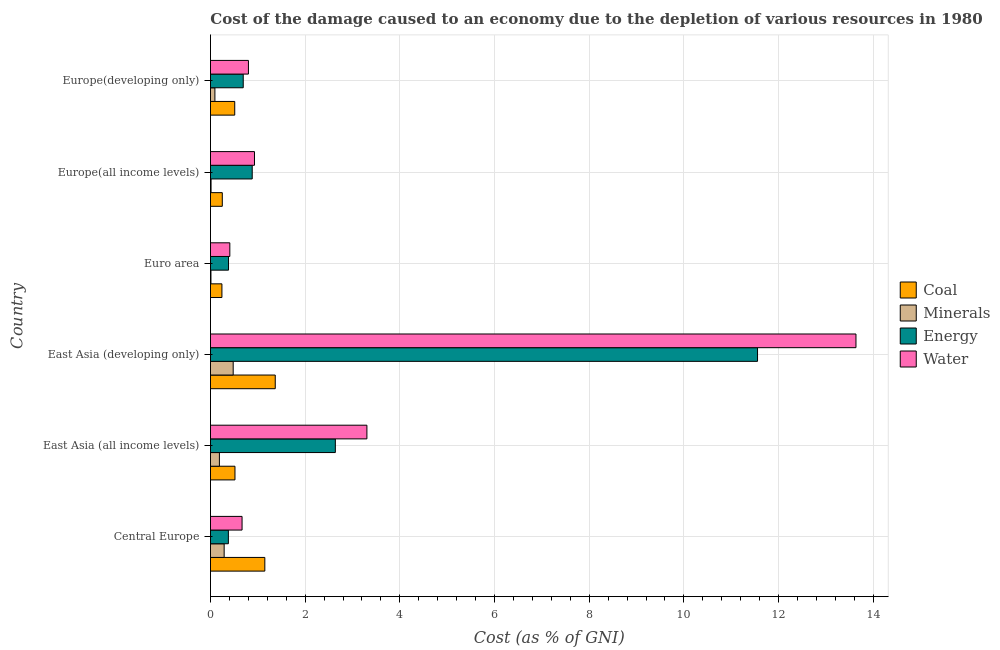How many groups of bars are there?
Make the answer very short. 6. Are the number of bars per tick equal to the number of legend labels?
Your answer should be very brief. Yes. What is the label of the 2nd group of bars from the top?
Give a very brief answer. Europe(all income levels). What is the cost of damage due to depletion of minerals in Euro area?
Keep it short and to the point. 0.01. Across all countries, what is the maximum cost of damage due to depletion of energy?
Offer a terse response. 11.55. Across all countries, what is the minimum cost of damage due to depletion of coal?
Your response must be concise. 0.24. In which country was the cost of damage due to depletion of minerals maximum?
Keep it short and to the point. East Asia (developing only). What is the total cost of damage due to depletion of coal in the graph?
Ensure brevity in your answer.  4.04. What is the difference between the cost of damage due to depletion of coal in Central Europe and the cost of damage due to depletion of water in East Asia (all income levels)?
Offer a terse response. -2.16. What is the average cost of damage due to depletion of water per country?
Keep it short and to the point. 3.29. What is the difference between the cost of damage due to depletion of energy and cost of damage due to depletion of minerals in East Asia (all income levels)?
Provide a short and direct response. 2.45. In how many countries, is the cost of damage due to depletion of water greater than 1.6 %?
Make the answer very short. 2. What is the ratio of the cost of damage due to depletion of energy in East Asia (all income levels) to that in Europe(developing only)?
Give a very brief answer. 3.81. Is the difference between the cost of damage due to depletion of water in Central Europe and East Asia (developing only) greater than the difference between the cost of damage due to depletion of energy in Central Europe and East Asia (developing only)?
Offer a very short reply. No. What is the difference between the highest and the second highest cost of damage due to depletion of coal?
Ensure brevity in your answer.  0.22. What is the difference between the highest and the lowest cost of damage due to depletion of coal?
Your answer should be very brief. 1.13. In how many countries, is the cost of damage due to depletion of energy greater than the average cost of damage due to depletion of energy taken over all countries?
Provide a succinct answer. 1. Is the sum of the cost of damage due to depletion of coal in Central Europe and Europe(all income levels) greater than the maximum cost of damage due to depletion of energy across all countries?
Your response must be concise. No. What does the 3rd bar from the top in East Asia (all income levels) represents?
Ensure brevity in your answer.  Minerals. What does the 3rd bar from the bottom in Europe(developing only) represents?
Your response must be concise. Energy. Are all the bars in the graph horizontal?
Your answer should be compact. Yes. Are the values on the major ticks of X-axis written in scientific E-notation?
Make the answer very short. No. How many legend labels are there?
Make the answer very short. 4. What is the title of the graph?
Offer a very short reply. Cost of the damage caused to an economy due to the depletion of various resources in 1980 . Does "Agriculture" appear as one of the legend labels in the graph?
Keep it short and to the point. No. What is the label or title of the X-axis?
Offer a terse response. Cost (as % of GNI). What is the Cost (as % of GNI) in Coal in Central Europe?
Keep it short and to the point. 1.15. What is the Cost (as % of GNI) of Minerals in Central Europe?
Provide a succinct answer. 0.29. What is the Cost (as % of GNI) in Energy in Central Europe?
Ensure brevity in your answer.  0.38. What is the Cost (as % of GNI) of Water in Central Europe?
Ensure brevity in your answer.  0.67. What is the Cost (as % of GNI) of Coal in East Asia (all income levels)?
Give a very brief answer. 0.52. What is the Cost (as % of GNI) in Minerals in East Asia (all income levels)?
Offer a very short reply. 0.19. What is the Cost (as % of GNI) of Energy in East Asia (all income levels)?
Provide a short and direct response. 2.64. What is the Cost (as % of GNI) of Water in East Asia (all income levels)?
Keep it short and to the point. 3.3. What is the Cost (as % of GNI) of Coal in East Asia (developing only)?
Make the answer very short. 1.37. What is the Cost (as % of GNI) in Minerals in East Asia (developing only)?
Your response must be concise. 0.48. What is the Cost (as % of GNI) of Energy in East Asia (developing only)?
Your answer should be compact. 11.55. What is the Cost (as % of GNI) in Water in East Asia (developing only)?
Your response must be concise. 13.63. What is the Cost (as % of GNI) in Coal in Euro area?
Your response must be concise. 0.24. What is the Cost (as % of GNI) in Minerals in Euro area?
Provide a short and direct response. 0.01. What is the Cost (as % of GNI) of Energy in Euro area?
Provide a short and direct response. 0.38. What is the Cost (as % of GNI) in Water in Euro area?
Your response must be concise. 0.41. What is the Cost (as % of GNI) of Coal in Europe(all income levels)?
Keep it short and to the point. 0.25. What is the Cost (as % of GNI) of Minerals in Europe(all income levels)?
Offer a very short reply. 0.01. What is the Cost (as % of GNI) of Energy in Europe(all income levels)?
Provide a succinct answer. 0.88. What is the Cost (as % of GNI) of Water in Europe(all income levels)?
Keep it short and to the point. 0.93. What is the Cost (as % of GNI) in Coal in Europe(developing only)?
Offer a very short reply. 0.51. What is the Cost (as % of GNI) in Minerals in Europe(developing only)?
Ensure brevity in your answer.  0.09. What is the Cost (as % of GNI) of Energy in Europe(developing only)?
Provide a short and direct response. 0.69. What is the Cost (as % of GNI) of Water in Europe(developing only)?
Your response must be concise. 0.8. Across all countries, what is the maximum Cost (as % of GNI) in Coal?
Make the answer very short. 1.37. Across all countries, what is the maximum Cost (as % of GNI) of Minerals?
Keep it short and to the point. 0.48. Across all countries, what is the maximum Cost (as % of GNI) of Energy?
Provide a succinct answer. 11.55. Across all countries, what is the maximum Cost (as % of GNI) in Water?
Ensure brevity in your answer.  13.63. Across all countries, what is the minimum Cost (as % of GNI) in Coal?
Keep it short and to the point. 0.24. Across all countries, what is the minimum Cost (as % of GNI) in Minerals?
Your answer should be very brief. 0.01. Across all countries, what is the minimum Cost (as % of GNI) in Energy?
Your answer should be very brief. 0.38. Across all countries, what is the minimum Cost (as % of GNI) of Water?
Your answer should be compact. 0.41. What is the total Cost (as % of GNI) of Coal in the graph?
Keep it short and to the point. 4.04. What is the total Cost (as % of GNI) of Minerals in the graph?
Your answer should be compact. 1.07. What is the total Cost (as % of GNI) of Energy in the graph?
Your answer should be compact. 16.53. What is the total Cost (as % of GNI) in Water in the graph?
Make the answer very short. 19.75. What is the difference between the Cost (as % of GNI) of Coal in Central Europe and that in East Asia (all income levels)?
Offer a terse response. 0.63. What is the difference between the Cost (as % of GNI) of Minerals in Central Europe and that in East Asia (all income levels)?
Ensure brevity in your answer.  0.1. What is the difference between the Cost (as % of GNI) in Energy in Central Europe and that in East Asia (all income levels)?
Offer a terse response. -2.26. What is the difference between the Cost (as % of GNI) in Water in Central Europe and that in East Asia (all income levels)?
Ensure brevity in your answer.  -2.64. What is the difference between the Cost (as % of GNI) in Coal in Central Europe and that in East Asia (developing only)?
Make the answer very short. -0.22. What is the difference between the Cost (as % of GNI) of Minerals in Central Europe and that in East Asia (developing only)?
Provide a succinct answer. -0.19. What is the difference between the Cost (as % of GNI) in Energy in Central Europe and that in East Asia (developing only)?
Your response must be concise. -11.18. What is the difference between the Cost (as % of GNI) of Water in Central Europe and that in East Asia (developing only)?
Offer a terse response. -12.97. What is the difference between the Cost (as % of GNI) in Coal in Central Europe and that in Euro area?
Offer a terse response. 0.91. What is the difference between the Cost (as % of GNI) of Minerals in Central Europe and that in Euro area?
Make the answer very short. 0.28. What is the difference between the Cost (as % of GNI) of Energy in Central Europe and that in Euro area?
Your response must be concise. -0. What is the difference between the Cost (as % of GNI) of Water in Central Europe and that in Euro area?
Give a very brief answer. 0.26. What is the difference between the Cost (as % of GNI) of Coal in Central Europe and that in Europe(all income levels)?
Offer a very short reply. 0.9. What is the difference between the Cost (as % of GNI) in Minerals in Central Europe and that in Europe(all income levels)?
Your answer should be compact. 0.28. What is the difference between the Cost (as % of GNI) in Energy in Central Europe and that in Europe(all income levels)?
Provide a succinct answer. -0.5. What is the difference between the Cost (as % of GNI) of Water in Central Europe and that in Europe(all income levels)?
Your response must be concise. -0.26. What is the difference between the Cost (as % of GNI) of Coal in Central Europe and that in Europe(developing only)?
Offer a terse response. 0.64. What is the difference between the Cost (as % of GNI) of Minerals in Central Europe and that in Europe(developing only)?
Offer a terse response. 0.2. What is the difference between the Cost (as % of GNI) in Energy in Central Europe and that in Europe(developing only)?
Offer a terse response. -0.31. What is the difference between the Cost (as % of GNI) in Water in Central Europe and that in Europe(developing only)?
Ensure brevity in your answer.  -0.13. What is the difference between the Cost (as % of GNI) of Coal in East Asia (all income levels) and that in East Asia (developing only)?
Make the answer very short. -0.85. What is the difference between the Cost (as % of GNI) of Minerals in East Asia (all income levels) and that in East Asia (developing only)?
Give a very brief answer. -0.29. What is the difference between the Cost (as % of GNI) of Energy in East Asia (all income levels) and that in East Asia (developing only)?
Offer a terse response. -8.92. What is the difference between the Cost (as % of GNI) of Water in East Asia (all income levels) and that in East Asia (developing only)?
Provide a succinct answer. -10.33. What is the difference between the Cost (as % of GNI) in Coal in East Asia (all income levels) and that in Euro area?
Your answer should be compact. 0.28. What is the difference between the Cost (as % of GNI) of Minerals in East Asia (all income levels) and that in Euro area?
Provide a succinct answer. 0.18. What is the difference between the Cost (as % of GNI) in Energy in East Asia (all income levels) and that in Euro area?
Make the answer very short. 2.26. What is the difference between the Cost (as % of GNI) in Water in East Asia (all income levels) and that in Euro area?
Make the answer very short. 2.9. What is the difference between the Cost (as % of GNI) of Coal in East Asia (all income levels) and that in Europe(all income levels)?
Make the answer very short. 0.27. What is the difference between the Cost (as % of GNI) in Minerals in East Asia (all income levels) and that in Europe(all income levels)?
Make the answer very short. 0.18. What is the difference between the Cost (as % of GNI) in Energy in East Asia (all income levels) and that in Europe(all income levels)?
Ensure brevity in your answer.  1.76. What is the difference between the Cost (as % of GNI) in Water in East Asia (all income levels) and that in Europe(all income levels)?
Your response must be concise. 2.37. What is the difference between the Cost (as % of GNI) in Coal in East Asia (all income levels) and that in Europe(developing only)?
Keep it short and to the point. 0. What is the difference between the Cost (as % of GNI) of Minerals in East Asia (all income levels) and that in Europe(developing only)?
Your answer should be very brief. 0.1. What is the difference between the Cost (as % of GNI) of Energy in East Asia (all income levels) and that in Europe(developing only)?
Give a very brief answer. 1.95. What is the difference between the Cost (as % of GNI) in Water in East Asia (all income levels) and that in Europe(developing only)?
Offer a very short reply. 2.5. What is the difference between the Cost (as % of GNI) in Coal in East Asia (developing only) and that in Euro area?
Keep it short and to the point. 1.13. What is the difference between the Cost (as % of GNI) of Minerals in East Asia (developing only) and that in Euro area?
Ensure brevity in your answer.  0.47. What is the difference between the Cost (as % of GNI) in Energy in East Asia (developing only) and that in Euro area?
Offer a very short reply. 11.17. What is the difference between the Cost (as % of GNI) of Water in East Asia (developing only) and that in Euro area?
Provide a short and direct response. 13.22. What is the difference between the Cost (as % of GNI) of Coal in East Asia (developing only) and that in Europe(all income levels)?
Provide a short and direct response. 1.12. What is the difference between the Cost (as % of GNI) in Minerals in East Asia (developing only) and that in Europe(all income levels)?
Your answer should be very brief. 0.47. What is the difference between the Cost (as % of GNI) in Energy in East Asia (developing only) and that in Europe(all income levels)?
Offer a terse response. 10.67. What is the difference between the Cost (as % of GNI) of Water in East Asia (developing only) and that in Europe(all income levels)?
Your response must be concise. 12.7. What is the difference between the Cost (as % of GNI) in Coal in East Asia (developing only) and that in Europe(developing only)?
Ensure brevity in your answer.  0.86. What is the difference between the Cost (as % of GNI) of Minerals in East Asia (developing only) and that in Europe(developing only)?
Keep it short and to the point. 0.39. What is the difference between the Cost (as % of GNI) in Energy in East Asia (developing only) and that in Europe(developing only)?
Ensure brevity in your answer.  10.86. What is the difference between the Cost (as % of GNI) of Water in East Asia (developing only) and that in Europe(developing only)?
Keep it short and to the point. 12.83. What is the difference between the Cost (as % of GNI) in Coal in Euro area and that in Europe(all income levels)?
Keep it short and to the point. -0.01. What is the difference between the Cost (as % of GNI) in Minerals in Euro area and that in Europe(all income levels)?
Offer a terse response. -0. What is the difference between the Cost (as % of GNI) of Energy in Euro area and that in Europe(all income levels)?
Provide a short and direct response. -0.5. What is the difference between the Cost (as % of GNI) in Water in Euro area and that in Europe(all income levels)?
Give a very brief answer. -0.52. What is the difference between the Cost (as % of GNI) of Coal in Euro area and that in Europe(developing only)?
Make the answer very short. -0.27. What is the difference between the Cost (as % of GNI) of Minerals in Euro area and that in Europe(developing only)?
Offer a very short reply. -0.08. What is the difference between the Cost (as % of GNI) in Energy in Euro area and that in Europe(developing only)?
Make the answer very short. -0.31. What is the difference between the Cost (as % of GNI) in Water in Euro area and that in Europe(developing only)?
Provide a succinct answer. -0.39. What is the difference between the Cost (as % of GNI) in Coal in Europe(all income levels) and that in Europe(developing only)?
Keep it short and to the point. -0.26. What is the difference between the Cost (as % of GNI) of Minerals in Europe(all income levels) and that in Europe(developing only)?
Your answer should be compact. -0.08. What is the difference between the Cost (as % of GNI) in Energy in Europe(all income levels) and that in Europe(developing only)?
Your response must be concise. 0.19. What is the difference between the Cost (as % of GNI) of Water in Europe(all income levels) and that in Europe(developing only)?
Offer a very short reply. 0.13. What is the difference between the Cost (as % of GNI) of Coal in Central Europe and the Cost (as % of GNI) of Minerals in East Asia (all income levels)?
Your response must be concise. 0.96. What is the difference between the Cost (as % of GNI) in Coal in Central Europe and the Cost (as % of GNI) in Energy in East Asia (all income levels)?
Your response must be concise. -1.49. What is the difference between the Cost (as % of GNI) in Coal in Central Europe and the Cost (as % of GNI) in Water in East Asia (all income levels)?
Provide a short and direct response. -2.16. What is the difference between the Cost (as % of GNI) of Minerals in Central Europe and the Cost (as % of GNI) of Energy in East Asia (all income levels)?
Provide a succinct answer. -2.35. What is the difference between the Cost (as % of GNI) in Minerals in Central Europe and the Cost (as % of GNI) in Water in East Asia (all income levels)?
Your response must be concise. -3.02. What is the difference between the Cost (as % of GNI) of Energy in Central Europe and the Cost (as % of GNI) of Water in East Asia (all income levels)?
Provide a short and direct response. -2.93. What is the difference between the Cost (as % of GNI) in Coal in Central Europe and the Cost (as % of GNI) in Minerals in East Asia (developing only)?
Make the answer very short. 0.67. What is the difference between the Cost (as % of GNI) of Coal in Central Europe and the Cost (as % of GNI) of Energy in East Asia (developing only)?
Ensure brevity in your answer.  -10.41. What is the difference between the Cost (as % of GNI) in Coal in Central Europe and the Cost (as % of GNI) in Water in East Asia (developing only)?
Keep it short and to the point. -12.49. What is the difference between the Cost (as % of GNI) of Minerals in Central Europe and the Cost (as % of GNI) of Energy in East Asia (developing only)?
Your answer should be compact. -11.27. What is the difference between the Cost (as % of GNI) in Minerals in Central Europe and the Cost (as % of GNI) in Water in East Asia (developing only)?
Provide a succinct answer. -13.34. What is the difference between the Cost (as % of GNI) in Energy in Central Europe and the Cost (as % of GNI) in Water in East Asia (developing only)?
Give a very brief answer. -13.26. What is the difference between the Cost (as % of GNI) of Coal in Central Europe and the Cost (as % of GNI) of Minerals in Euro area?
Ensure brevity in your answer.  1.14. What is the difference between the Cost (as % of GNI) of Coal in Central Europe and the Cost (as % of GNI) of Energy in Euro area?
Ensure brevity in your answer.  0.77. What is the difference between the Cost (as % of GNI) of Coal in Central Europe and the Cost (as % of GNI) of Water in Euro area?
Your answer should be compact. 0.74. What is the difference between the Cost (as % of GNI) of Minerals in Central Europe and the Cost (as % of GNI) of Energy in Euro area?
Provide a succinct answer. -0.09. What is the difference between the Cost (as % of GNI) of Minerals in Central Europe and the Cost (as % of GNI) of Water in Euro area?
Ensure brevity in your answer.  -0.12. What is the difference between the Cost (as % of GNI) in Energy in Central Europe and the Cost (as % of GNI) in Water in Euro area?
Your response must be concise. -0.03. What is the difference between the Cost (as % of GNI) in Coal in Central Europe and the Cost (as % of GNI) in Minerals in Europe(all income levels)?
Offer a terse response. 1.14. What is the difference between the Cost (as % of GNI) in Coal in Central Europe and the Cost (as % of GNI) in Energy in Europe(all income levels)?
Provide a succinct answer. 0.27. What is the difference between the Cost (as % of GNI) in Coal in Central Europe and the Cost (as % of GNI) in Water in Europe(all income levels)?
Your answer should be compact. 0.22. What is the difference between the Cost (as % of GNI) of Minerals in Central Europe and the Cost (as % of GNI) of Energy in Europe(all income levels)?
Give a very brief answer. -0.59. What is the difference between the Cost (as % of GNI) of Minerals in Central Europe and the Cost (as % of GNI) of Water in Europe(all income levels)?
Your response must be concise. -0.64. What is the difference between the Cost (as % of GNI) in Energy in Central Europe and the Cost (as % of GNI) in Water in Europe(all income levels)?
Keep it short and to the point. -0.55. What is the difference between the Cost (as % of GNI) of Coal in Central Europe and the Cost (as % of GNI) of Minerals in Europe(developing only)?
Give a very brief answer. 1.05. What is the difference between the Cost (as % of GNI) in Coal in Central Europe and the Cost (as % of GNI) in Energy in Europe(developing only)?
Ensure brevity in your answer.  0.46. What is the difference between the Cost (as % of GNI) in Coal in Central Europe and the Cost (as % of GNI) in Water in Europe(developing only)?
Provide a succinct answer. 0.35. What is the difference between the Cost (as % of GNI) in Minerals in Central Europe and the Cost (as % of GNI) in Energy in Europe(developing only)?
Provide a short and direct response. -0.4. What is the difference between the Cost (as % of GNI) in Minerals in Central Europe and the Cost (as % of GNI) in Water in Europe(developing only)?
Provide a short and direct response. -0.51. What is the difference between the Cost (as % of GNI) of Energy in Central Europe and the Cost (as % of GNI) of Water in Europe(developing only)?
Keep it short and to the point. -0.42. What is the difference between the Cost (as % of GNI) of Coal in East Asia (all income levels) and the Cost (as % of GNI) of Minerals in East Asia (developing only)?
Offer a terse response. 0.04. What is the difference between the Cost (as % of GNI) in Coal in East Asia (all income levels) and the Cost (as % of GNI) in Energy in East Asia (developing only)?
Your response must be concise. -11.04. What is the difference between the Cost (as % of GNI) in Coal in East Asia (all income levels) and the Cost (as % of GNI) in Water in East Asia (developing only)?
Your answer should be very brief. -13.12. What is the difference between the Cost (as % of GNI) in Minerals in East Asia (all income levels) and the Cost (as % of GNI) in Energy in East Asia (developing only)?
Your answer should be very brief. -11.37. What is the difference between the Cost (as % of GNI) in Minerals in East Asia (all income levels) and the Cost (as % of GNI) in Water in East Asia (developing only)?
Your answer should be very brief. -13.45. What is the difference between the Cost (as % of GNI) of Energy in East Asia (all income levels) and the Cost (as % of GNI) of Water in East Asia (developing only)?
Provide a short and direct response. -11. What is the difference between the Cost (as % of GNI) in Coal in East Asia (all income levels) and the Cost (as % of GNI) in Minerals in Euro area?
Give a very brief answer. 0.51. What is the difference between the Cost (as % of GNI) in Coal in East Asia (all income levels) and the Cost (as % of GNI) in Energy in Euro area?
Ensure brevity in your answer.  0.14. What is the difference between the Cost (as % of GNI) in Coal in East Asia (all income levels) and the Cost (as % of GNI) in Water in Euro area?
Make the answer very short. 0.11. What is the difference between the Cost (as % of GNI) in Minerals in East Asia (all income levels) and the Cost (as % of GNI) in Energy in Euro area?
Ensure brevity in your answer.  -0.19. What is the difference between the Cost (as % of GNI) of Minerals in East Asia (all income levels) and the Cost (as % of GNI) of Water in Euro area?
Provide a succinct answer. -0.22. What is the difference between the Cost (as % of GNI) in Energy in East Asia (all income levels) and the Cost (as % of GNI) in Water in Euro area?
Give a very brief answer. 2.23. What is the difference between the Cost (as % of GNI) of Coal in East Asia (all income levels) and the Cost (as % of GNI) of Minerals in Europe(all income levels)?
Provide a short and direct response. 0.5. What is the difference between the Cost (as % of GNI) in Coal in East Asia (all income levels) and the Cost (as % of GNI) in Energy in Europe(all income levels)?
Your response must be concise. -0.36. What is the difference between the Cost (as % of GNI) in Coal in East Asia (all income levels) and the Cost (as % of GNI) in Water in Europe(all income levels)?
Offer a very short reply. -0.41. What is the difference between the Cost (as % of GNI) in Minerals in East Asia (all income levels) and the Cost (as % of GNI) in Energy in Europe(all income levels)?
Offer a terse response. -0.69. What is the difference between the Cost (as % of GNI) in Minerals in East Asia (all income levels) and the Cost (as % of GNI) in Water in Europe(all income levels)?
Provide a succinct answer. -0.74. What is the difference between the Cost (as % of GNI) in Energy in East Asia (all income levels) and the Cost (as % of GNI) in Water in Europe(all income levels)?
Keep it short and to the point. 1.71. What is the difference between the Cost (as % of GNI) of Coal in East Asia (all income levels) and the Cost (as % of GNI) of Minerals in Europe(developing only)?
Provide a short and direct response. 0.42. What is the difference between the Cost (as % of GNI) in Coal in East Asia (all income levels) and the Cost (as % of GNI) in Energy in Europe(developing only)?
Your answer should be compact. -0.17. What is the difference between the Cost (as % of GNI) of Coal in East Asia (all income levels) and the Cost (as % of GNI) of Water in Europe(developing only)?
Offer a very short reply. -0.28. What is the difference between the Cost (as % of GNI) in Minerals in East Asia (all income levels) and the Cost (as % of GNI) in Energy in Europe(developing only)?
Give a very brief answer. -0.5. What is the difference between the Cost (as % of GNI) in Minerals in East Asia (all income levels) and the Cost (as % of GNI) in Water in Europe(developing only)?
Ensure brevity in your answer.  -0.61. What is the difference between the Cost (as % of GNI) of Energy in East Asia (all income levels) and the Cost (as % of GNI) of Water in Europe(developing only)?
Ensure brevity in your answer.  1.84. What is the difference between the Cost (as % of GNI) of Coal in East Asia (developing only) and the Cost (as % of GNI) of Minerals in Euro area?
Offer a terse response. 1.36. What is the difference between the Cost (as % of GNI) of Coal in East Asia (developing only) and the Cost (as % of GNI) of Energy in Euro area?
Offer a terse response. 0.99. What is the difference between the Cost (as % of GNI) of Coal in East Asia (developing only) and the Cost (as % of GNI) of Water in Euro area?
Your answer should be very brief. 0.96. What is the difference between the Cost (as % of GNI) of Minerals in East Asia (developing only) and the Cost (as % of GNI) of Energy in Euro area?
Ensure brevity in your answer.  0.1. What is the difference between the Cost (as % of GNI) in Minerals in East Asia (developing only) and the Cost (as % of GNI) in Water in Euro area?
Your response must be concise. 0.07. What is the difference between the Cost (as % of GNI) of Energy in East Asia (developing only) and the Cost (as % of GNI) of Water in Euro area?
Give a very brief answer. 11.15. What is the difference between the Cost (as % of GNI) in Coal in East Asia (developing only) and the Cost (as % of GNI) in Minerals in Europe(all income levels)?
Provide a succinct answer. 1.36. What is the difference between the Cost (as % of GNI) in Coal in East Asia (developing only) and the Cost (as % of GNI) in Energy in Europe(all income levels)?
Your answer should be compact. 0.49. What is the difference between the Cost (as % of GNI) in Coal in East Asia (developing only) and the Cost (as % of GNI) in Water in Europe(all income levels)?
Provide a succinct answer. 0.44. What is the difference between the Cost (as % of GNI) in Minerals in East Asia (developing only) and the Cost (as % of GNI) in Energy in Europe(all income levels)?
Your answer should be very brief. -0.4. What is the difference between the Cost (as % of GNI) in Minerals in East Asia (developing only) and the Cost (as % of GNI) in Water in Europe(all income levels)?
Keep it short and to the point. -0.45. What is the difference between the Cost (as % of GNI) of Energy in East Asia (developing only) and the Cost (as % of GNI) of Water in Europe(all income levels)?
Make the answer very short. 10.63. What is the difference between the Cost (as % of GNI) of Coal in East Asia (developing only) and the Cost (as % of GNI) of Minerals in Europe(developing only)?
Your answer should be very brief. 1.27. What is the difference between the Cost (as % of GNI) of Coal in East Asia (developing only) and the Cost (as % of GNI) of Energy in Europe(developing only)?
Ensure brevity in your answer.  0.68. What is the difference between the Cost (as % of GNI) in Coal in East Asia (developing only) and the Cost (as % of GNI) in Water in Europe(developing only)?
Give a very brief answer. 0.57. What is the difference between the Cost (as % of GNI) of Minerals in East Asia (developing only) and the Cost (as % of GNI) of Energy in Europe(developing only)?
Give a very brief answer. -0.21. What is the difference between the Cost (as % of GNI) of Minerals in East Asia (developing only) and the Cost (as % of GNI) of Water in Europe(developing only)?
Your answer should be very brief. -0.32. What is the difference between the Cost (as % of GNI) in Energy in East Asia (developing only) and the Cost (as % of GNI) in Water in Europe(developing only)?
Offer a terse response. 10.75. What is the difference between the Cost (as % of GNI) in Coal in Euro area and the Cost (as % of GNI) in Minerals in Europe(all income levels)?
Provide a short and direct response. 0.23. What is the difference between the Cost (as % of GNI) of Coal in Euro area and the Cost (as % of GNI) of Energy in Europe(all income levels)?
Make the answer very short. -0.64. What is the difference between the Cost (as % of GNI) of Coal in Euro area and the Cost (as % of GNI) of Water in Europe(all income levels)?
Your response must be concise. -0.69. What is the difference between the Cost (as % of GNI) of Minerals in Euro area and the Cost (as % of GNI) of Energy in Europe(all income levels)?
Offer a very short reply. -0.87. What is the difference between the Cost (as % of GNI) of Minerals in Euro area and the Cost (as % of GNI) of Water in Europe(all income levels)?
Keep it short and to the point. -0.92. What is the difference between the Cost (as % of GNI) in Energy in Euro area and the Cost (as % of GNI) in Water in Europe(all income levels)?
Provide a short and direct response. -0.55. What is the difference between the Cost (as % of GNI) in Coal in Euro area and the Cost (as % of GNI) in Minerals in Europe(developing only)?
Provide a succinct answer. 0.15. What is the difference between the Cost (as % of GNI) in Coal in Euro area and the Cost (as % of GNI) in Energy in Europe(developing only)?
Keep it short and to the point. -0.45. What is the difference between the Cost (as % of GNI) of Coal in Euro area and the Cost (as % of GNI) of Water in Europe(developing only)?
Your response must be concise. -0.56. What is the difference between the Cost (as % of GNI) of Minerals in Euro area and the Cost (as % of GNI) of Energy in Europe(developing only)?
Your answer should be very brief. -0.68. What is the difference between the Cost (as % of GNI) in Minerals in Euro area and the Cost (as % of GNI) in Water in Europe(developing only)?
Make the answer very short. -0.79. What is the difference between the Cost (as % of GNI) in Energy in Euro area and the Cost (as % of GNI) in Water in Europe(developing only)?
Your answer should be very brief. -0.42. What is the difference between the Cost (as % of GNI) of Coal in Europe(all income levels) and the Cost (as % of GNI) of Minerals in Europe(developing only)?
Ensure brevity in your answer.  0.16. What is the difference between the Cost (as % of GNI) in Coal in Europe(all income levels) and the Cost (as % of GNI) in Energy in Europe(developing only)?
Offer a terse response. -0.44. What is the difference between the Cost (as % of GNI) of Coal in Europe(all income levels) and the Cost (as % of GNI) of Water in Europe(developing only)?
Offer a terse response. -0.55. What is the difference between the Cost (as % of GNI) of Minerals in Europe(all income levels) and the Cost (as % of GNI) of Energy in Europe(developing only)?
Provide a short and direct response. -0.68. What is the difference between the Cost (as % of GNI) in Minerals in Europe(all income levels) and the Cost (as % of GNI) in Water in Europe(developing only)?
Offer a terse response. -0.79. What is the difference between the Cost (as % of GNI) in Energy in Europe(all income levels) and the Cost (as % of GNI) in Water in Europe(developing only)?
Your response must be concise. 0.08. What is the average Cost (as % of GNI) in Coal per country?
Your response must be concise. 0.67. What is the average Cost (as % of GNI) in Minerals per country?
Offer a very short reply. 0.18. What is the average Cost (as % of GNI) of Energy per country?
Offer a terse response. 2.75. What is the average Cost (as % of GNI) in Water per country?
Your answer should be compact. 3.29. What is the difference between the Cost (as % of GNI) of Coal and Cost (as % of GNI) of Minerals in Central Europe?
Offer a terse response. 0.86. What is the difference between the Cost (as % of GNI) in Coal and Cost (as % of GNI) in Energy in Central Europe?
Offer a very short reply. 0.77. What is the difference between the Cost (as % of GNI) in Coal and Cost (as % of GNI) in Water in Central Europe?
Provide a short and direct response. 0.48. What is the difference between the Cost (as % of GNI) in Minerals and Cost (as % of GNI) in Energy in Central Europe?
Provide a succinct answer. -0.09. What is the difference between the Cost (as % of GNI) of Minerals and Cost (as % of GNI) of Water in Central Europe?
Ensure brevity in your answer.  -0.38. What is the difference between the Cost (as % of GNI) of Energy and Cost (as % of GNI) of Water in Central Europe?
Give a very brief answer. -0.29. What is the difference between the Cost (as % of GNI) of Coal and Cost (as % of GNI) of Minerals in East Asia (all income levels)?
Provide a short and direct response. 0.33. What is the difference between the Cost (as % of GNI) in Coal and Cost (as % of GNI) in Energy in East Asia (all income levels)?
Ensure brevity in your answer.  -2.12. What is the difference between the Cost (as % of GNI) of Coal and Cost (as % of GNI) of Water in East Asia (all income levels)?
Make the answer very short. -2.79. What is the difference between the Cost (as % of GNI) in Minerals and Cost (as % of GNI) in Energy in East Asia (all income levels)?
Make the answer very short. -2.45. What is the difference between the Cost (as % of GNI) in Minerals and Cost (as % of GNI) in Water in East Asia (all income levels)?
Your answer should be very brief. -3.12. What is the difference between the Cost (as % of GNI) in Energy and Cost (as % of GNI) in Water in East Asia (all income levels)?
Provide a short and direct response. -0.67. What is the difference between the Cost (as % of GNI) of Coal and Cost (as % of GNI) of Minerals in East Asia (developing only)?
Keep it short and to the point. 0.89. What is the difference between the Cost (as % of GNI) in Coal and Cost (as % of GNI) in Energy in East Asia (developing only)?
Offer a terse response. -10.19. What is the difference between the Cost (as % of GNI) in Coal and Cost (as % of GNI) in Water in East Asia (developing only)?
Offer a very short reply. -12.27. What is the difference between the Cost (as % of GNI) of Minerals and Cost (as % of GNI) of Energy in East Asia (developing only)?
Your response must be concise. -11.07. What is the difference between the Cost (as % of GNI) of Minerals and Cost (as % of GNI) of Water in East Asia (developing only)?
Keep it short and to the point. -13.15. What is the difference between the Cost (as % of GNI) in Energy and Cost (as % of GNI) in Water in East Asia (developing only)?
Provide a succinct answer. -2.08. What is the difference between the Cost (as % of GNI) in Coal and Cost (as % of GNI) in Minerals in Euro area?
Offer a terse response. 0.23. What is the difference between the Cost (as % of GNI) of Coal and Cost (as % of GNI) of Energy in Euro area?
Your answer should be compact. -0.14. What is the difference between the Cost (as % of GNI) of Coal and Cost (as % of GNI) of Water in Euro area?
Make the answer very short. -0.17. What is the difference between the Cost (as % of GNI) of Minerals and Cost (as % of GNI) of Energy in Euro area?
Make the answer very short. -0.37. What is the difference between the Cost (as % of GNI) of Minerals and Cost (as % of GNI) of Water in Euro area?
Provide a short and direct response. -0.4. What is the difference between the Cost (as % of GNI) in Energy and Cost (as % of GNI) in Water in Euro area?
Ensure brevity in your answer.  -0.03. What is the difference between the Cost (as % of GNI) of Coal and Cost (as % of GNI) of Minerals in Europe(all income levels)?
Make the answer very short. 0.24. What is the difference between the Cost (as % of GNI) of Coal and Cost (as % of GNI) of Energy in Europe(all income levels)?
Your answer should be very brief. -0.63. What is the difference between the Cost (as % of GNI) in Coal and Cost (as % of GNI) in Water in Europe(all income levels)?
Keep it short and to the point. -0.68. What is the difference between the Cost (as % of GNI) in Minerals and Cost (as % of GNI) in Energy in Europe(all income levels)?
Give a very brief answer. -0.87. What is the difference between the Cost (as % of GNI) of Minerals and Cost (as % of GNI) of Water in Europe(all income levels)?
Your response must be concise. -0.92. What is the difference between the Cost (as % of GNI) in Energy and Cost (as % of GNI) in Water in Europe(all income levels)?
Your answer should be compact. -0.05. What is the difference between the Cost (as % of GNI) of Coal and Cost (as % of GNI) of Minerals in Europe(developing only)?
Keep it short and to the point. 0.42. What is the difference between the Cost (as % of GNI) of Coal and Cost (as % of GNI) of Energy in Europe(developing only)?
Your answer should be compact. -0.18. What is the difference between the Cost (as % of GNI) in Coal and Cost (as % of GNI) in Water in Europe(developing only)?
Your answer should be very brief. -0.29. What is the difference between the Cost (as % of GNI) in Minerals and Cost (as % of GNI) in Energy in Europe(developing only)?
Ensure brevity in your answer.  -0.6. What is the difference between the Cost (as % of GNI) of Minerals and Cost (as % of GNI) of Water in Europe(developing only)?
Your answer should be very brief. -0.71. What is the difference between the Cost (as % of GNI) of Energy and Cost (as % of GNI) of Water in Europe(developing only)?
Your response must be concise. -0.11. What is the ratio of the Cost (as % of GNI) in Coal in Central Europe to that in East Asia (all income levels)?
Provide a short and direct response. 2.22. What is the ratio of the Cost (as % of GNI) in Minerals in Central Europe to that in East Asia (all income levels)?
Offer a terse response. 1.53. What is the ratio of the Cost (as % of GNI) of Energy in Central Europe to that in East Asia (all income levels)?
Provide a succinct answer. 0.14. What is the ratio of the Cost (as % of GNI) of Water in Central Europe to that in East Asia (all income levels)?
Provide a succinct answer. 0.2. What is the ratio of the Cost (as % of GNI) of Coal in Central Europe to that in East Asia (developing only)?
Offer a terse response. 0.84. What is the ratio of the Cost (as % of GNI) of Minerals in Central Europe to that in East Asia (developing only)?
Your answer should be compact. 0.6. What is the ratio of the Cost (as % of GNI) in Energy in Central Europe to that in East Asia (developing only)?
Make the answer very short. 0.03. What is the ratio of the Cost (as % of GNI) of Water in Central Europe to that in East Asia (developing only)?
Offer a very short reply. 0.05. What is the ratio of the Cost (as % of GNI) in Coal in Central Europe to that in Euro area?
Give a very brief answer. 4.75. What is the ratio of the Cost (as % of GNI) of Minerals in Central Europe to that in Euro area?
Provide a short and direct response. 28.81. What is the ratio of the Cost (as % of GNI) in Energy in Central Europe to that in Euro area?
Provide a short and direct response. 0.99. What is the ratio of the Cost (as % of GNI) of Water in Central Europe to that in Euro area?
Your response must be concise. 1.63. What is the ratio of the Cost (as % of GNI) of Coal in Central Europe to that in Europe(all income levels)?
Provide a short and direct response. 4.6. What is the ratio of the Cost (as % of GNI) of Minerals in Central Europe to that in Europe(all income levels)?
Give a very brief answer. 23.05. What is the ratio of the Cost (as % of GNI) of Energy in Central Europe to that in Europe(all income levels)?
Ensure brevity in your answer.  0.43. What is the ratio of the Cost (as % of GNI) of Water in Central Europe to that in Europe(all income levels)?
Offer a very short reply. 0.72. What is the ratio of the Cost (as % of GNI) of Coal in Central Europe to that in Europe(developing only)?
Provide a short and direct response. 2.24. What is the ratio of the Cost (as % of GNI) in Minerals in Central Europe to that in Europe(developing only)?
Keep it short and to the point. 3.09. What is the ratio of the Cost (as % of GNI) in Energy in Central Europe to that in Europe(developing only)?
Your answer should be very brief. 0.55. What is the ratio of the Cost (as % of GNI) in Water in Central Europe to that in Europe(developing only)?
Make the answer very short. 0.83. What is the ratio of the Cost (as % of GNI) of Coal in East Asia (all income levels) to that in East Asia (developing only)?
Offer a terse response. 0.38. What is the ratio of the Cost (as % of GNI) of Minerals in East Asia (all income levels) to that in East Asia (developing only)?
Offer a very short reply. 0.39. What is the ratio of the Cost (as % of GNI) of Energy in East Asia (all income levels) to that in East Asia (developing only)?
Make the answer very short. 0.23. What is the ratio of the Cost (as % of GNI) of Water in East Asia (all income levels) to that in East Asia (developing only)?
Your answer should be very brief. 0.24. What is the ratio of the Cost (as % of GNI) of Coal in East Asia (all income levels) to that in Euro area?
Offer a terse response. 2.14. What is the ratio of the Cost (as % of GNI) in Minerals in East Asia (all income levels) to that in Euro area?
Ensure brevity in your answer.  18.81. What is the ratio of the Cost (as % of GNI) of Energy in East Asia (all income levels) to that in Euro area?
Ensure brevity in your answer.  6.92. What is the ratio of the Cost (as % of GNI) of Water in East Asia (all income levels) to that in Euro area?
Your answer should be compact. 8.08. What is the ratio of the Cost (as % of GNI) of Coal in East Asia (all income levels) to that in Europe(all income levels)?
Your answer should be compact. 2.07. What is the ratio of the Cost (as % of GNI) in Minerals in East Asia (all income levels) to that in Europe(all income levels)?
Your answer should be compact. 15.06. What is the ratio of the Cost (as % of GNI) in Energy in East Asia (all income levels) to that in Europe(all income levels)?
Offer a terse response. 2.99. What is the ratio of the Cost (as % of GNI) in Water in East Asia (all income levels) to that in Europe(all income levels)?
Your response must be concise. 3.55. What is the ratio of the Cost (as % of GNI) in Coal in East Asia (all income levels) to that in Europe(developing only)?
Make the answer very short. 1.01. What is the ratio of the Cost (as % of GNI) in Minerals in East Asia (all income levels) to that in Europe(developing only)?
Offer a terse response. 2.02. What is the ratio of the Cost (as % of GNI) in Energy in East Asia (all income levels) to that in Europe(developing only)?
Provide a succinct answer. 3.81. What is the ratio of the Cost (as % of GNI) in Water in East Asia (all income levels) to that in Europe(developing only)?
Offer a terse response. 4.12. What is the ratio of the Cost (as % of GNI) in Coal in East Asia (developing only) to that in Euro area?
Your answer should be very brief. 5.66. What is the ratio of the Cost (as % of GNI) in Minerals in East Asia (developing only) to that in Euro area?
Offer a very short reply. 47.82. What is the ratio of the Cost (as % of GNI) in Energy in East Asia (developing only) to that in Euro area?
Your answer should be compact. 30.31. What is the ratio of the Cost (as % of GNI) of Water in East Asia (developing only) to that in Euro area?
Ensure brevity in your answer.  33.34. What is the ratio of the Cost (as % of GNI) of Coal in East Asia (developing only) to that in Europe(all income levels)?
Your answer should be compact. 5.48. What is the ratio of the Cost (as % of GNI) in Minerals in East Asia (developing only) to that in Europe(all income levels)?
Your answer should be very brief. 38.27. What is the ratio of the Cost (as % of GNI) of Energy in East Asia (developing only) to that in Europe(all income levels)?
Keep it short and to the point. 13.1. What is the ratio of the Cost (as % of GNI) of Water in East Asia (developing only) to that in Europe(all income levels)?
Give a very brief answer. 14.67. What is the ratio of the Cost (as % of GNI) in Coal in East Asia (developing only) to that in Europe(developing only)?
Your answer should be compact. 2.67. What is the ratio of the Cost (as % of GNI) of Minerals in East Asia (developing only) to that in Europe(developing only)?
Offer a terse response. 5.13. What is the ratio of the Cost (as % of GNI) in Energy in East Asia (developing only) to that in Europe(developing only)?
Provide a succinct answer. 16.7. What is the ratio of the Cost (as % of GNI) of Water in East Asia (developing only) to that in Europe(developing only)?
Keep it short and to the point. 17. What is the ratio of the Cost (as % of GNI) in Coal in Euro area to that in Europe(all income levels)?
Offer a terse response. 0.97. What is the ratio of the Cost (as % of GNI) of Minerals in Euro area to that in Europe(all income levels)?
Give a very brief answer. 0.8. What is the ratio of the Cost (as % of GNI) in Energy in Euro area to that in Europe(all income levels)?
Provide a succinct answer. 0.43. What is the ratio of the Cost (as % of GNI) in Water in Euro area to that in Europe(all income levels)?
Your response must be concise. 0.44. What is the ratio of the Cost (as % of GNI) in Coal in Euro area to that in Europe(developing only)?
Offer a very short reply. 0.47. What is the ratio of the Cost (as % of GNI) of Minerals in Euro area to that in Europe(developing only)?
Offer a very short reply. 0.11. What is the ratio of the Cost (as % of GNI) in Energy in Euro area to that in Europe(developing only)?
Your answer should be very brief. 0.55. What is the ratio of the Cost (as % of GNI) in Water in Euro area to that in Europe(developing only)?
Your answer should be very brief. 0.51. What is the ratio of the Cost (as % of GNI) in Coal in Europe(all income levels) to that in Europe(developing only)?
Your response must be concise. 0.49. What is the ratio of the Cost (as % of GNI) of Minerals in Europe(all income levels) to that in Europe(developing only)?
Offer a very short reply. 0.13. What is the ratio of the Cost (as % of GNI) of Energy in Europe(all income levels) to that in Europe(developing only)?
Offer a terse response. 1.27. What is the ratio of the Cost (as % of GNI) of Water in Europe(all income levels) to that in Europe(developing only)?
Your answer should be compact. 1.16. What is the difference between the highest and the second highest Cost (as % of GNI) of Coal?
Offer a terse response. 0.22. What is the difference between the highest and the second highest Cost (as % of GNI) of Minerals?
Give a very brief answer. 0.19. What is the difference between the highest and the second highest Cost (as % of GNI) in Energy?
Your response must be concise. 8.92. What is the difference between the highest and the second highest Cost (as % of GNI) of Water?
Provide a short and direct response. 10.33. What is the difference between the highest and the lowest Cost (as % of GNI) of Coal?
Ensure brevity in your answer.  1.13. What is the difference between the highest and the lowest Cost (as % of GNI) in Minerals?
Keep it short and to the point. 0.47. What is the difference between the highest and the lowest Cost (as % of GNI) of Energy?
Your answer should be very brief. 11.18. What is the difference between the highest and the lowest Cost (as % of GNI) of Water?
Make the answer very short. 13.22. 